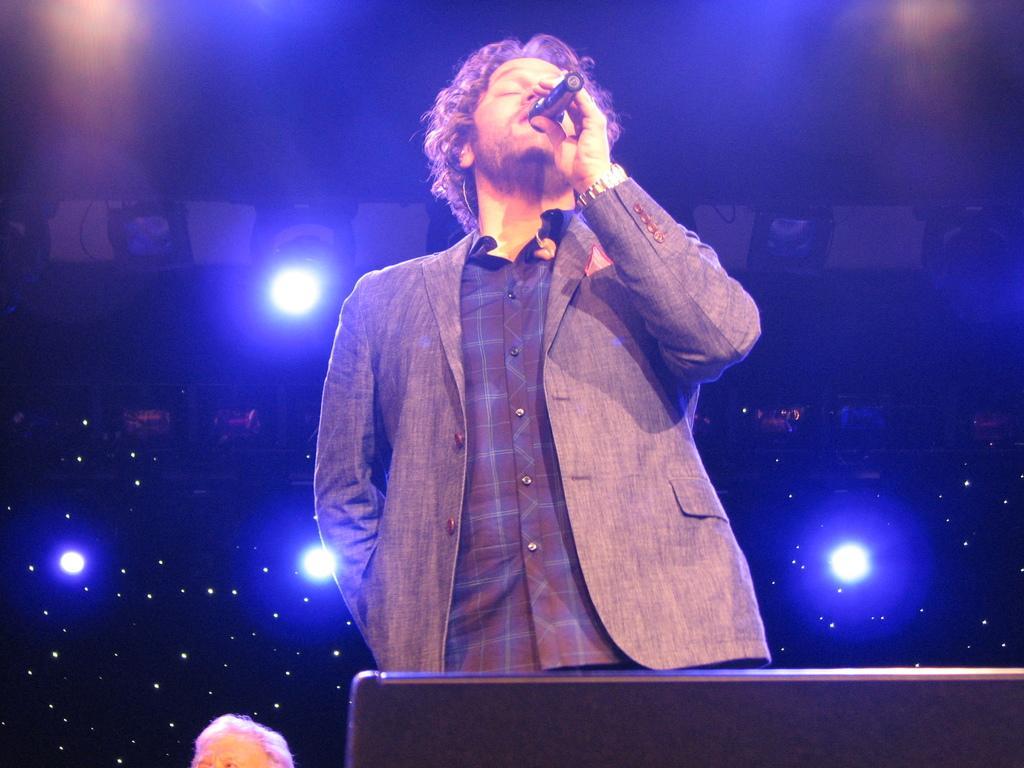How would you summarize this image in a sentence or two? There is a man singing on the mike and he is in a suit. In the background there are lights. 